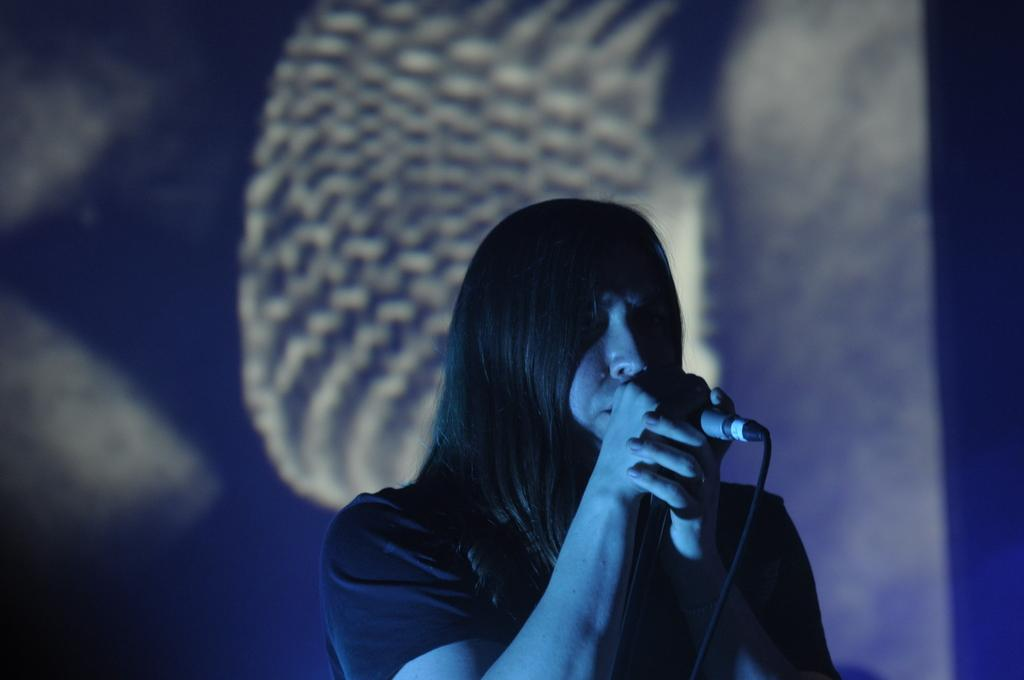What is the main subject of the image? The main subject of the image is a woman. Where is the woman located in the image? The woman is in the center of the image. What is the woman doing in the image? The woman is singing. What object is associated with the woman's activity in the image? There is a microphone in the image. What type of meal is being prepared in the image? There is no meal preparation visible in the image; it features a woman singing with a microphone. What type of fire can be seen in the image? There is no fire present in the image. 